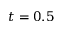<formula> <loc_0><loc_0><loc_500><loc_500>t = 0 . 5</formula> 